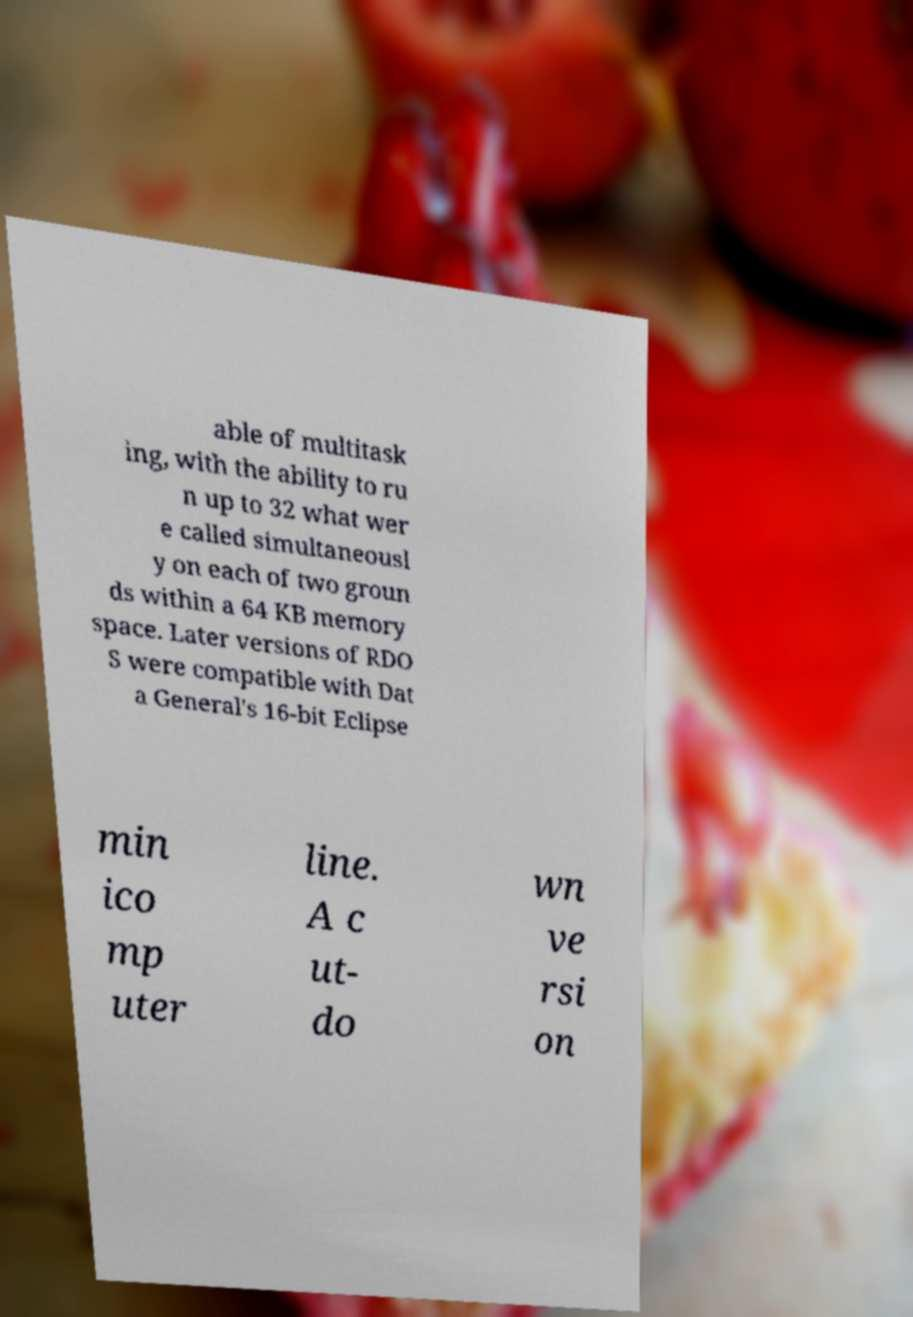Please identify and transcribe the text found in this image. able of multitask ing, with the ability to ru n up to 32 what wer e called simultaneousl y on each of two groun ds within a 64 KB memory space. Later versions of RDO S were compatible with Dat a General's 16-bit Eclipse min ico mp uter line. A c ut- do wn ve rsi on 